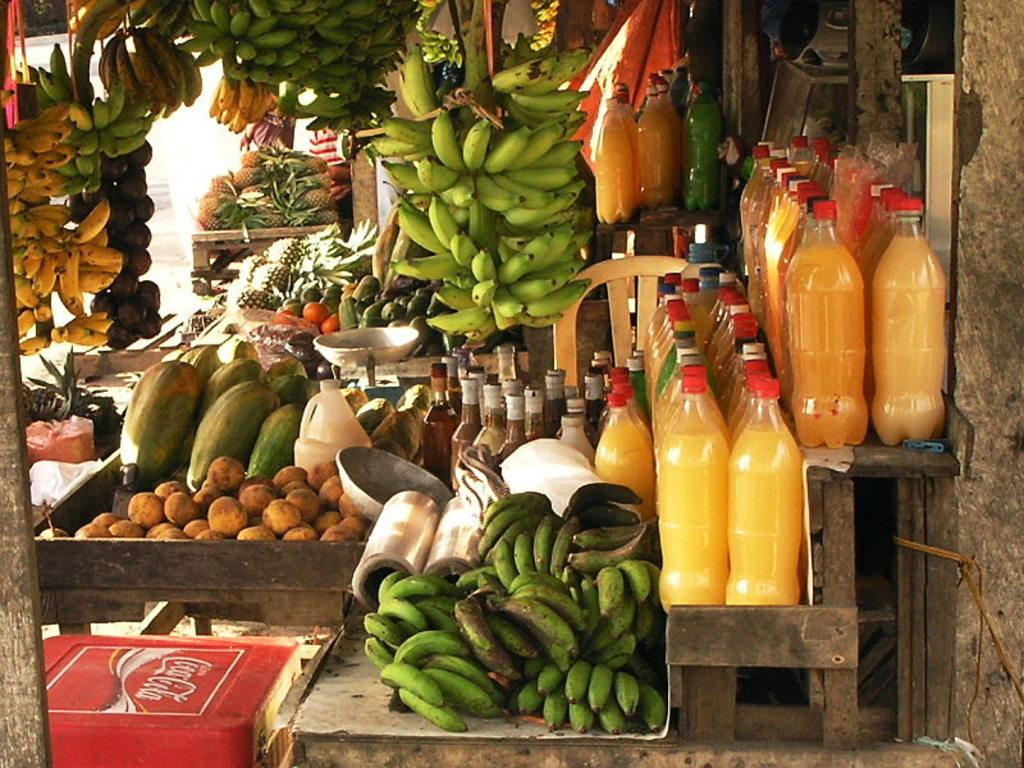What type of establishment is depicted in the image? There is a small store in the image. What types of food items can be found in the store? The store has vegetables and fruits. Where are the drinks located in the store? The drinks in bottles are on the right side of the store. Can you tell me how many toads are sitting on the shelves in the store? There are no toads present in the image; the store contains vegetables, fruits, and drinks in bottles. 